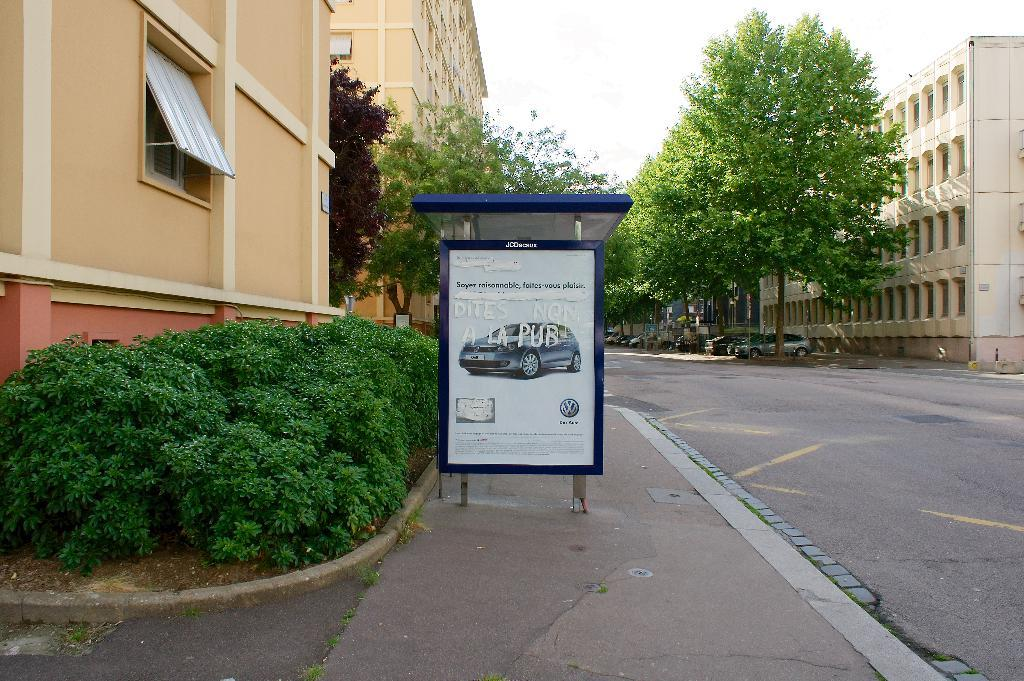What is located on the road in the image? There is a hoarding on the road in the image. What can be seen on the left side of the image? There are buildings on the left side of the image. What feature of the buildings is visible? There are windows visible on the buildings. What type of vegetation is present in the image? Plants and trees are present in the image. What is visible in the background of the image? Trees, buildings, vehicles, and the sky are visible in the background of the image. What type of coal distribution can be observed in the image? There is no coal or distribution of any kind present in the image. What nation is depicted in the image? The image does not depict any specific nation; it shows a road, buildings, and vegetation. 